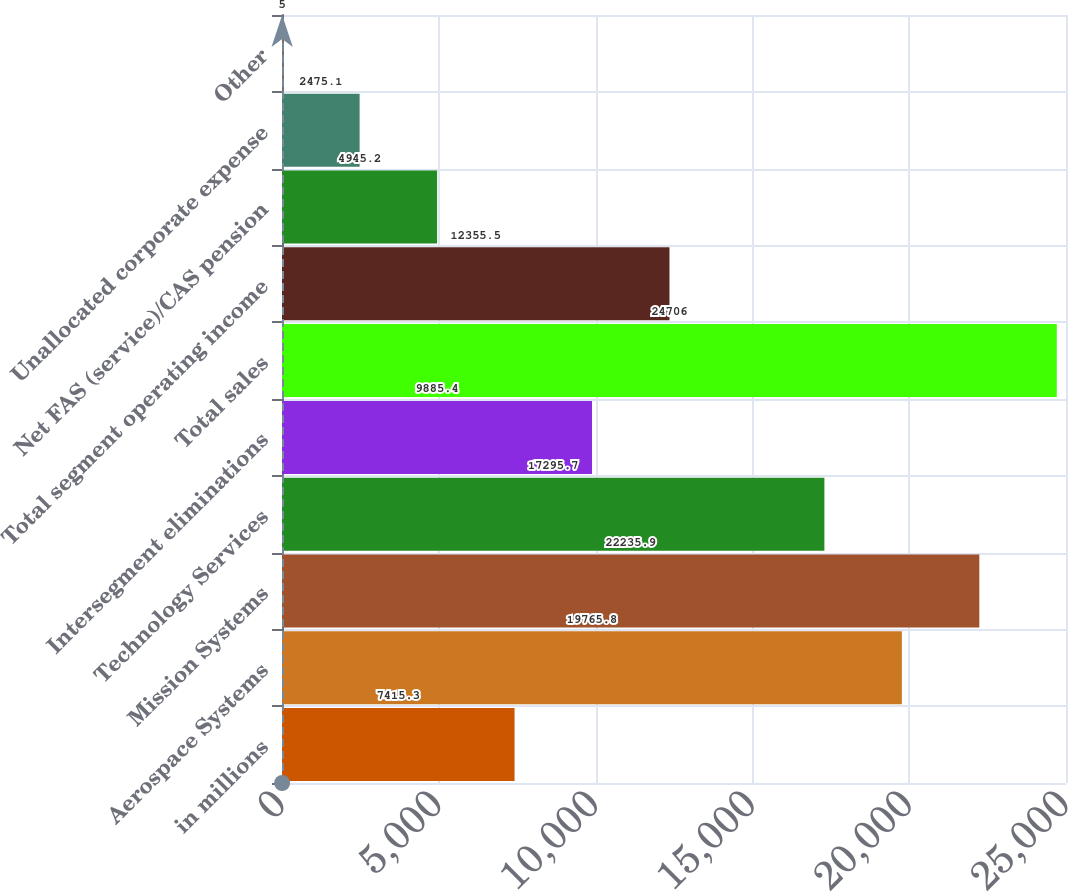Convert chart. <chart><loc_0><loc_0><loc_500><loc_500><bar_chart><fcel>in millions<fcel>Aerospace Systems<fcel>Mission Systems<fcel>Technology Services<fcel>Intersegment eliminations<fcel>Total sales<fcel>Total segment operating income<fcel>Net FAS (service)/CAS pension<fcel>Unallocated corporate expense<fcel>Other<nl><fcel>7415.3<fcel>19765.8<fcel>22235.9<fcel>17295.7<fcel>9885.4<fcel>24706<fcel>12355.5<fcel>4945.2<fcel>2475.1<fcel>5<nl></chart> 